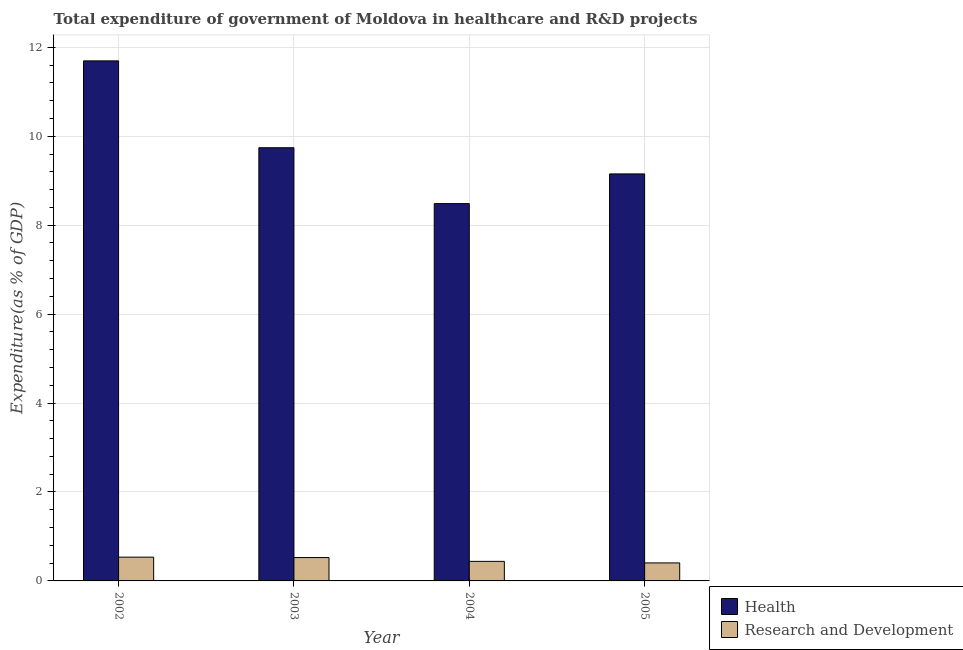How many bars are there on the 2nd tick from the left?
Provide a short and direct response. 2. What is the expenditure in healthcare in 2002?
Give a very brief answer. 11.7. Across all years, what is the maximum expenditure in r&d?
Keep it short and to the point. 0.53. Across all years, what is the minimum expenditure in healthcare?
Provide a succinct answer. 8.49. In which year was the expenditure in r&d maximum?
Ensure brevity in your answer.  2002. In which year was the expenditure in healthcare minimum?
Offer a very short reply. 2004. What is the total expenditure in healthcare in the graph?
Your answer should be compact. 39.08. What is the difference between the expenditure in r&d in 2003 and that in 2004?
Provide a succinct answer. 0.09. What is the difference between the expenditure in healthcare in 2005 and the expenditure in r&d in 2003?
Your response must be concise. -0.59. What is the average expenditure in healthcare per year?
Provide a succinct answer. 9.77. In how many years, is the expenditure in healthcare greater than 6.4 %?
Provide a succinct answer. 4. What is the ratio of the expenditure in r&d in 2002 to that in 2004?
Provide a short and direct response. 1.22. Is the expenditure in healthcare in 2003 less than that in 2004?
Offer a terse response. No. What is the difference between the highest and the second highest expenditure in healthcare?
Offer a very short reply. 1.95. What is the difference between the highest and the lowest expenditure in r&d?
Your answer should be very brief. 0.13. In how many years, is the expenditure in r&d greater than the average expenditure in r&d taken over all years?
Your answer should be very brief. 2. Is the sum of the expenditure in r&d in 2003 and 2004 greater than the maximum expenditure in healthcare across all years?
Keep it short and to the point. Yes. What does the 2nd bar from the left in 2003 represents?
Offer a terse response. Research and Development. What does the 2nd bar from the right in 2002 represents?
Give a very brief answer. Health. How many bars are there?
Offer a very short reply. 8. Are all the bars in the graph horizontal?
Ensure brevity in your answer.  No. How many years are there in the graph?
Your answer should be very brief. 4. Does the graph contain any zero values?
Your response must be concise. No. Does the graph contain grids?
Your answer should be compact. Yes. Where does the legend appear in the graph?
Your answer should be very brief. Bottom right. How many legend labels are there?
Make the answer very short. 2. How are the legend labels stacked?
Make the answer very short. Vertical. What is the title of the graph?
Your answer should be very brief. Total expenditure of government of Moldova in healthcare and R&D projects. Does "Under-five" appear as one of the legend labels in the graph?
Provide a succinct answer. No. What is the label or title of the X-axis?
Ensure brevity in your answer.  Year. What is the label or title of the Y-axis?
Your answer should be compact. Expenditure(as % of GDP). What is the Expenditure(as % of GDP) of Health in 2002?
Your answer should be compact. 11.7. What is the Expenditure(as % of GDP) in Research and Development in 2002?
Keep it short and to the point. 0.53. What is the Expenditure(as % of GDP) of Health in 2003?
Make the answer very short. 9.74. What is the Expenditure(as % of GDP) in Research and Development in 2003?
Make the answer very short. 0.53. What is the Expenditure(as % of GDP) of Health in 2004?
Make the answer very short. 8.49. What is the Expenditure(as % of GDP) of Research and Development in 2004?
Keep it short and to the point. 0.44. What is the Expenditure(as % of GDP) of Health in 2005?
Make the answer very short. 9.15. What is the Expenditure(as % of GDP) in Research and Development in 2005?
Your answer should be very brief. 0.4. Across all years, what is the maximum Expenditure(as % of GDP) in Health?
Your answer should be very brief. 11.7. Across all years, what is the maximum Expenditure(as % of GDP) of Research and Development?
Your answer should be compact. 0.53. Across all years, what is the minimum Expenditure(as % of GDP) of Health?
Offer a very short reply. 8.49. Across all years, what is the minimum Expenditure(as % of GDP) of Research and Development?
Make the answer very short. 0.4. What is the total Expenditure(as % of GDP) of Health in the graph?
Give a very brief answer. 39.08. What is the total Expenditure(as % of GDP) of Research and Development in the graph?
Your answer should be very brief. 1.91. What is the difference between the Expenditure(as % of GDP) of Health in 2002 and that in 2003?
Make the answer very short. 1.95. What is the difference between the Expenditure(as % of GDP) of Research and Development in 2002 and that in 2003?
Offer a terse response. 0.01. What is the difference between the Expenditure(as % of GDP) of Health in 2002 and that in 2004?
Your response must be concise. 3.21. What is the difference between the Expenditure(as % of GDP) of Research and Development in 2002 and that in 2004?
Your answer should be very brief. 0.09. What is the difference between the Expenditure(as % of GDP) of Health in 2002 and that in 2005?
Make the answer very short. 2.54. What is the difference between the Expenditure(as % of GDP) of Research and Development in 2002 and that in 2005?
Offer a very short reply. 0.13. What is the difference between the Expenditure(as % of GDP) of Health in 2003 and that in 2004?
Offer a very short reply. 1.26. What is the difference between the Expenditure(as % of GDP) in Research and Development in 2003 and that in 2004?
Your response must be concise. 0.09. What is the difference between the Expenditure(as % of GDP) in Health in 2003 and that in 2005?
Your answer should be very brief. 0.59. What is the difference between the Expenditure(as % of GDP) of Research and Development in 2003 and that in 2005?
Your answer should be very brief. 0.12. What is the difference between the Expenditure(as % of GDP) in Health in 2004 and that in 2005?
Ensure brevity in your answer.  -0.67. What is the difference between the Expenditure(as % of GDP) of Research and Development in 2004 and that in 2005?
Offer a terse response. 0.03. What is the difference between the Expenditure(as % of GDP) in Health in 2002 and the Expenditure(as % of GDP) in Research and Development in 2003?
Give a very brief answer. 11.17. What is the difference between the Expenditure(as % of GDP) in Health in 2002 and the Expenditure(as % of GDP) in Research and Development in 2004?
Provide a succinct answer. 11.26. What is the difference between the Expenditure(as % of GDP) of Health in 2002 and the Expenditure(as % of GDP) of Research and Development in 2005?
Provide a short and direct response. 11.29. What is the difference between the Expenditure(as % of GDP) of Health in 2003 and the Expenditure(as % of GDP) of Research and Development in 2004?
Make the answer very short. 9.3. What is the difference between the Expenditure(as % of GDP) of Health in 2003 and the Expenditure(as % of GDP) of Research and Development in 2005?
Offer a terse response. 9.34. What is the difference between the Expenditure(as % of GDP) of Health in 2004 and the Expenditure(as % of GDP) of Research and Development in 2005?
Provide a short and direct response. 8.08. What is the average Expenditure(as % of GDP) in Health per year?
Your response must be concise. 9.77. What is the average Expenditure(as % of GDP) of Research and Development per year?
Provide a short and direct response. 0.48. In the year 2002, what is the difference between the Expenditure(as % of GDP) in Health and Expenditure(as % of GDP) in Research and Development?
Give a very brief answer. 11.16. In the year 2003, what is the difference between the Expenditure(as % of GDP) of Health and Expenditure(as % of GDP) of Research and Development?
Keep it short and to the point. 9.22. In the year 2004, what is the difference between the Expenditure(as % of GDP) of Health and Expenditure(as % of GDP) of Research and Development?
Provide a succinct answer. 8.05. In the year 2005, what is the difference between the Expenditure(as % of GDP) in Health and Expenditure(as % of GDP) in Research and Development?
Your answer should be compact. 8.75. What is the ratio of the Expenditure(as % of GDP) in Health in 2002 to that in 2003?
Give a very brief answer. 1.2. What is the ratio of the Expenditure(as % of GDP) of Research and Development in 2002 to that in 2003?
Provide a succinct answer. 1.02. What is the ratio of the Expenditure(as % of GDP) of Health in 2002 to that in 2004?
Your answer should be compact. 1.38. What is the ratio of the Expenditure(as % of GDP) of Research and Development in 2002 to that in 2004?
Your answer should be very brief. 1.22. What is the ratio of the Expenditure(as % of GDP) of Health in 2002 to that in 2005?
Provide a succinct answer. 1.28. What is the ratio of the Expenditure(as % of GDP) of Research and Development in 2002 to that in 2005?
Your answer should be compact. 1.32. What is the ratio of the Expenditure(as % of GDP) in Health in 2003 to that in 2004?
Your answer should be very brief. 1.15. What is the ratio of the Expenditure(as % of GDP) in Research and Development in 2003 to that in 2004?
Ensure brevity in your answer.  1.19. What is the ratio of the Expenditure(as % of GDP) in Health in 2003 to that in 2005?
Give a very brief answer. 1.06. What is the ratio of the Expenditure(as % of GDP) in Research and Development in 2003 to that in 2005?
Ensure brevity in your answer.  1.3. What is the ratio of the Expenditure(as % of GDP) of Health in 2004 to that in 2005?
Provide a succinct answer. 0.93. What is the ratio of the Expenditure(as % of GDP) in Research and Development in 2004 to that in 2005?
Provide a short and direct response. 1.09. What is the difference between the highest and the second highest Expenditure(as % of GDP) in Health?
Keep it short and to the point. 1.95. What is the difference between the highest and the second highest Expenditure(as % of GDP) of Research and Development?
Your response must be concise. 0.01. What is the difference between the highest and the lowest Expenditure(as % of GDP) of Health?
Keep it short and to the point. 3.21. What is the difference between the highest and the lowest Expenditure(as % of GDP) of Research and Development?
Ensure brevity in your answer.  0.13. 